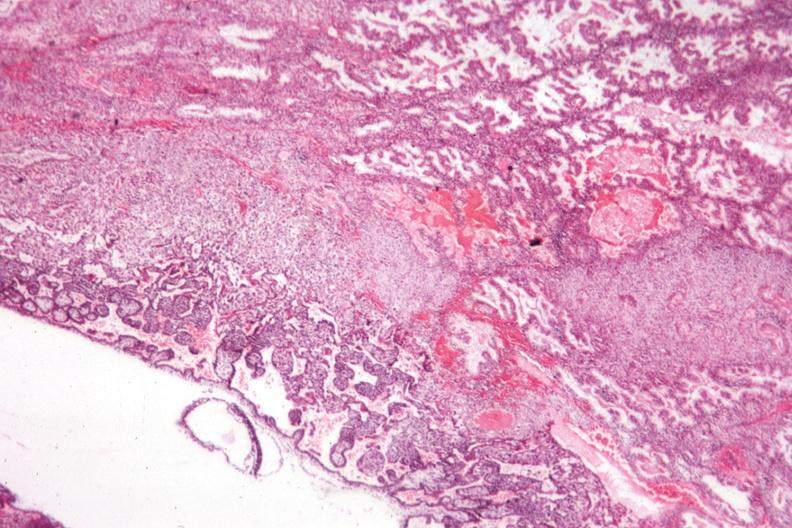does this image show shows early placental development?
Answer the question using a single word or phrase. Yes 